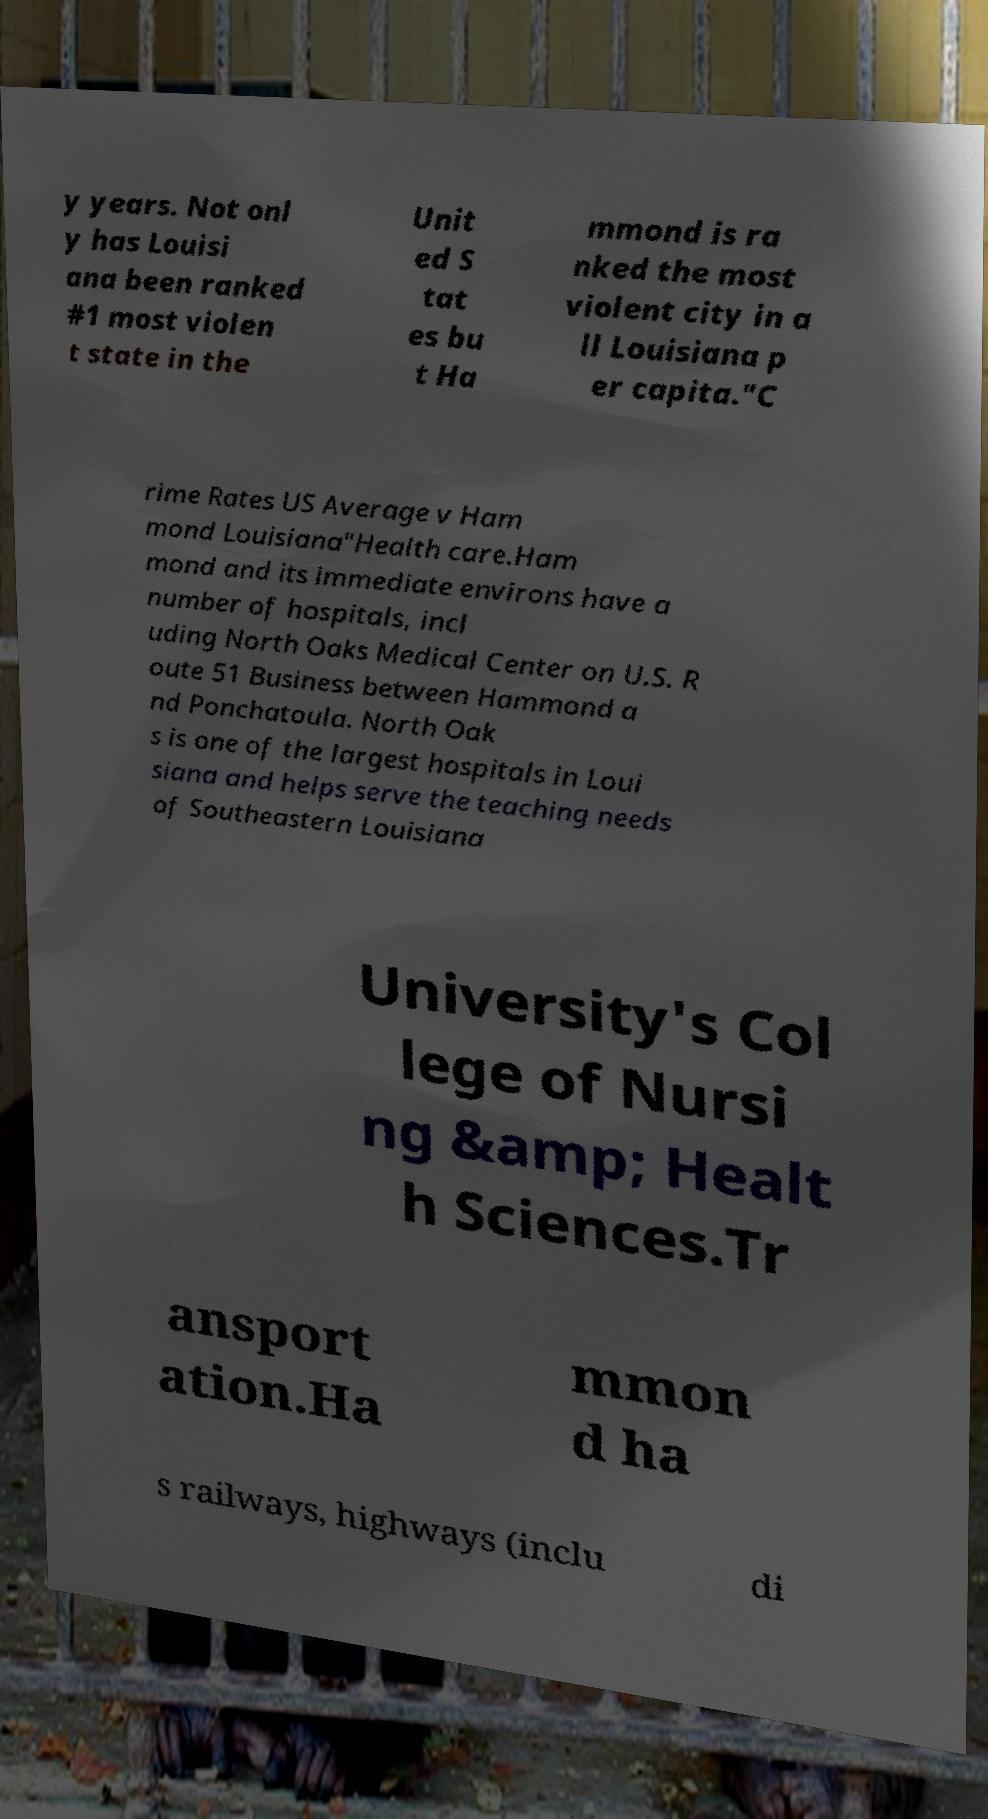There's text embedded in this image that I need extracted. Can you transcribe it verbatim? y years. Not onl y has Louisi ana been ranked #1 most violen t state in the Unit ed S tat es bu t Ha mmond is ra nked the most violent city in a ll Louisiana p er capita."C rime Rates US Average v Ham mond Louisiana"Health care.Ham mond and its immediate environs have a number of hospitals, incl uding North Oaks Medical Center on U.S. R oute 51 Business between Hammond a nd Ponchatoula. North Oak s is one of the largest hospitals in Loui siana and helps serve the teaching needs of Southeastern Louisiana University's Col lege of Nursi ng &amp; Healt h Sciences.Tr ansport ation.Ha mmon d ha s railways, highways (inclu di 